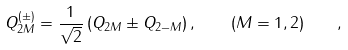<formula> <loc_0><loc_0><loc_500><loc_500>Q ^ { ( \pm ) } _ { 2 M } = \frac { 1 } { \sqrt { 2 } } \left ( Q _ { 2 M } \pm Q _ { 2 - M } \right ) , \quad ( M = 1 , 2 ) \quad ,</formula> 